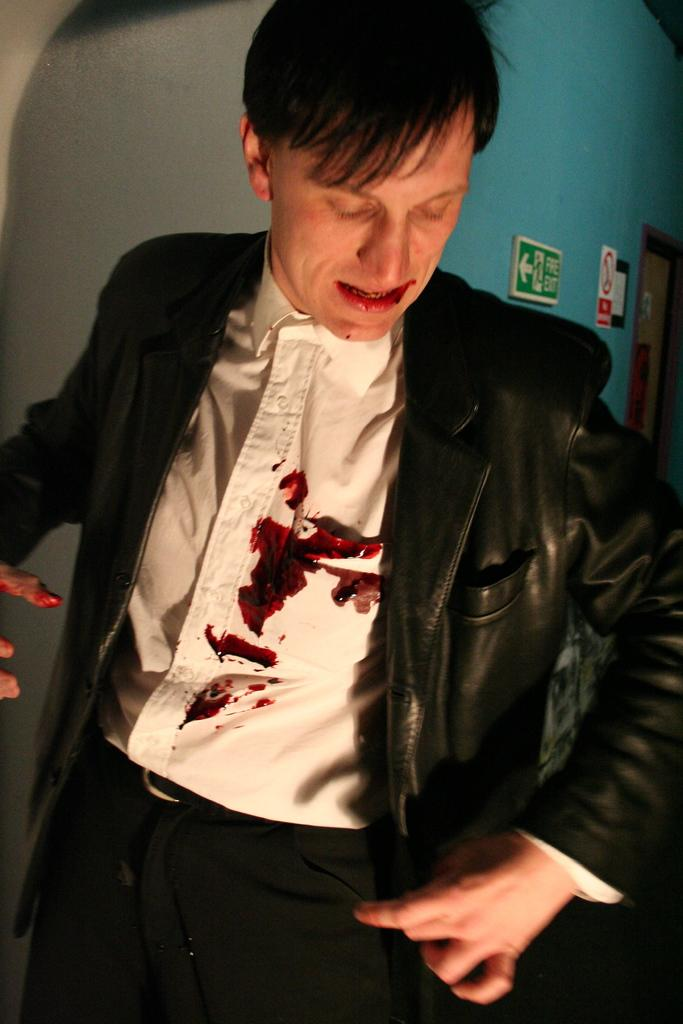Who is the main subject in the image? There is a man in the image. Where is the man positioned in the image? The man is standing in the center of the image. What can be seen on the right side of the image? There is a door on the right side of the image. What detail can be observed on the man's shirt? There are blood spots on the man's shirt. What type of creature is lurking behind the man in the image? There is no creature visible in the image; it only features a man standing in the center and a door on the right side. Can you tell me how many tickets the man is holding in the image? There is no mention of tickets in the image, and the man is not holding any visible objects. 